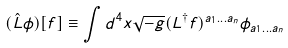Convert formula to latex. <formula><loc_0><loc_0><loc_500><loc_500>( \hat { L } \phi ) [ f ] \equiv \int d ^ { 4 } x \sqrt { - g } ( L ^ { \dagger } f ) ^ { a _ { 1 } \dots a _ { n } } \phi _ { a _ { 1 } \dots a _ { n } }</formula> 